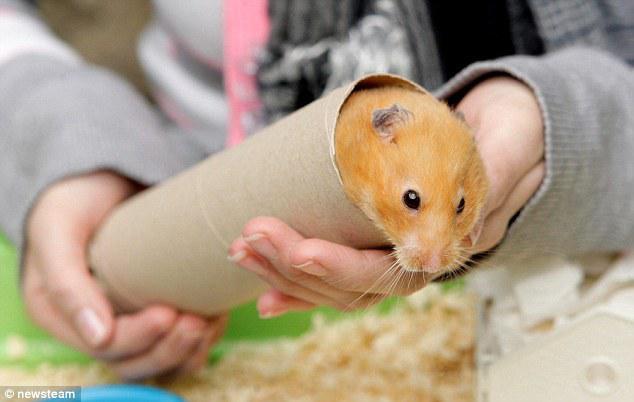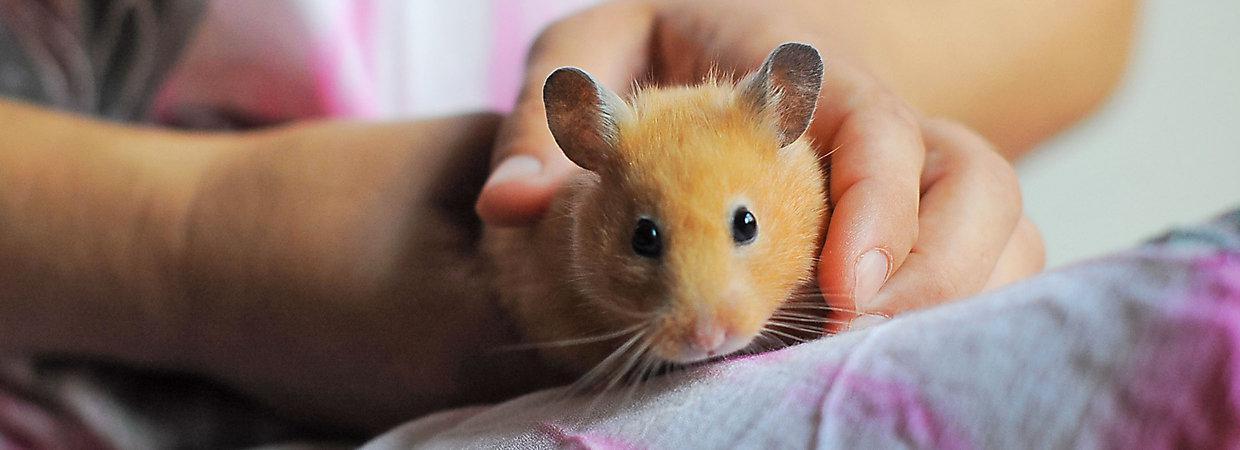The first image is the image on the left, the second image is the image on the right. For the images shown, is this caption "There is at least one human hand touching a rodent." true? Answer yes or no. Yes. The first image is the image on the left, the second image is the image on the right. Given the left and right images, does the statement "An item perforated with a hole is touched by a rodent standing behind it, in one image." hold true? Answer yes or no. No. 